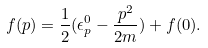Convert formula to latex. <formula><loc_0><loc_0><loc_500><loc_500>f ( { p } ) = \frac { 1 } { 2 } ( \epsilon _ { p } ^ { 0 } - \frac { { p } ^ { 2 } } { 2 m } ) + f ( 0 ) .</formula> 